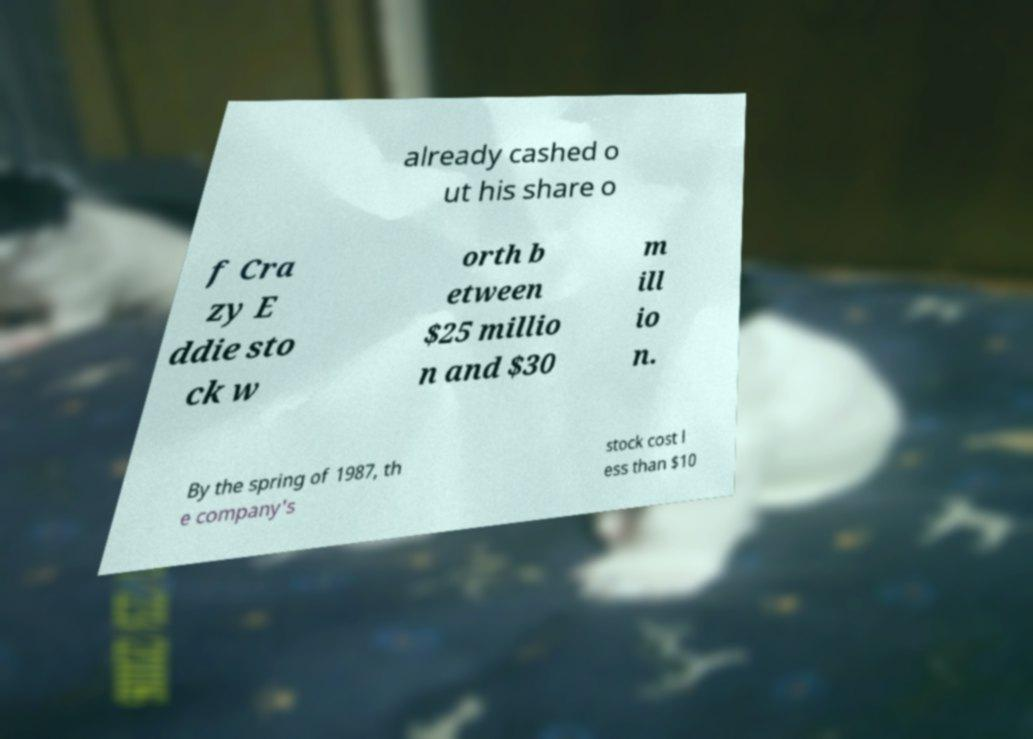I need the written content from this picture converted into text. Can you do that? already cashed o ut his share o f Cra zy E ddie sto ck w orth b etween $25 millio n and $30 m ill io n. By the spring of 1987, th e company's stock cost l ess than $10 